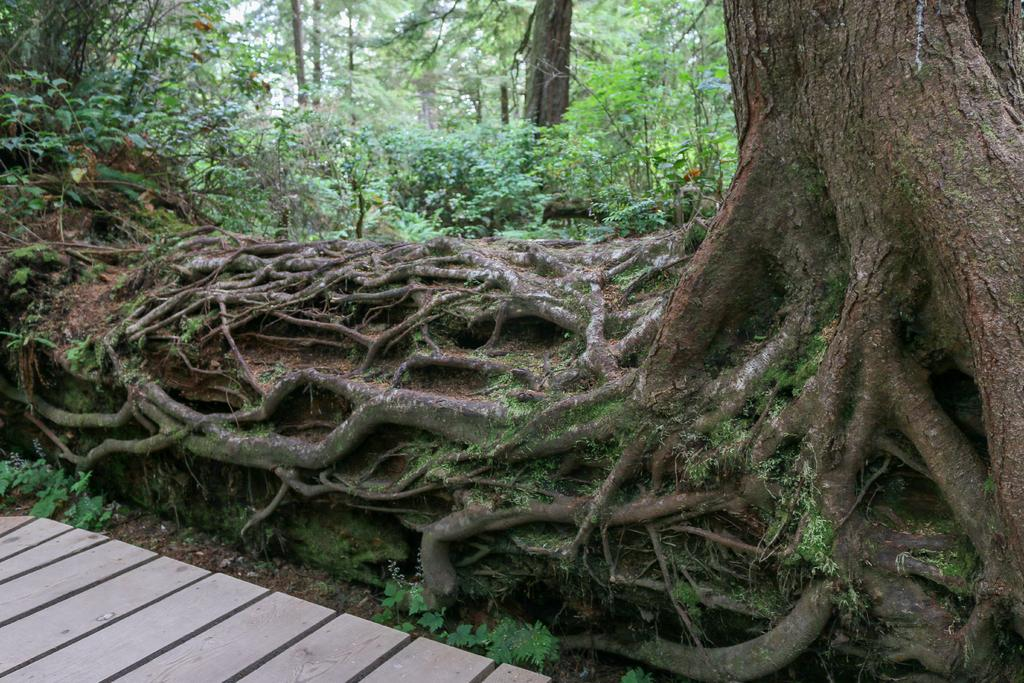What type of bridge is in the image? There is a wooden bridge in the image. Where is the wooden bridge located in the image? The wooden bridge is on the left side of the image. What other natural elements are present in the image? There are trees and plants in the image. How are the trees and plants positioned in relation to the wooden bridge? The trees and plants are located behind the wooden bridge. What month is it according to the calendar in the image? There is no calendar present in the image, so it is not possible to determine the month. 